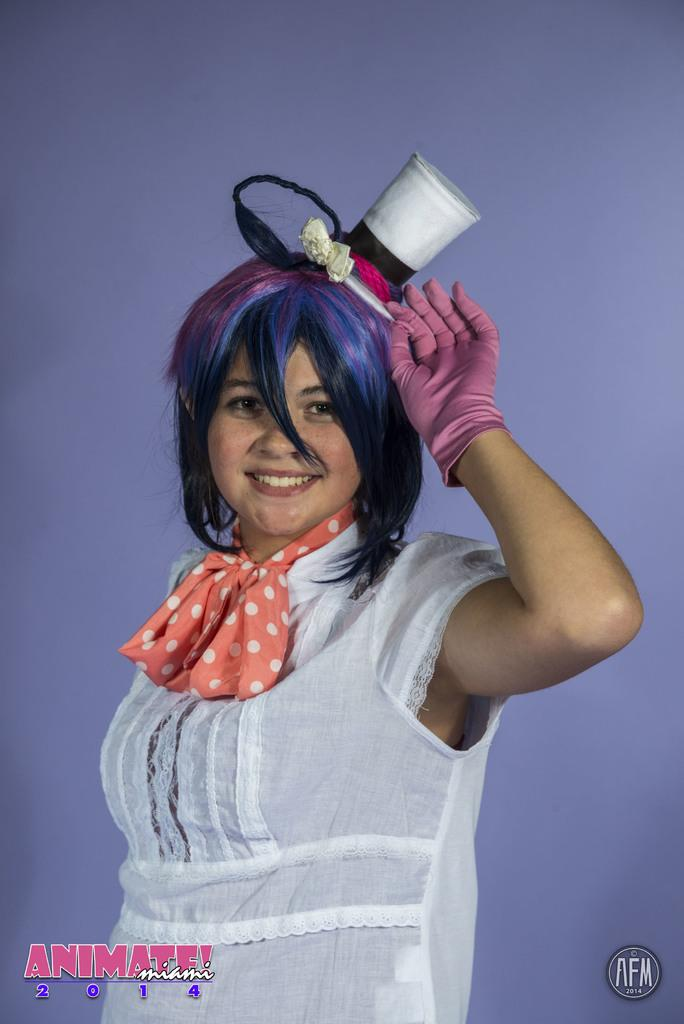Who is the main subject in the image? There is a lady in the center of the image. What is the lady wearing on her head? The lady is wearing a cap. What can be seen in the background of the image? There is a wall in the background of the image. How many geese are flying over the lady's head in the image? There are no geese present in the image. What type of quill is the lady holding in the image? There is no quill present in the image. 